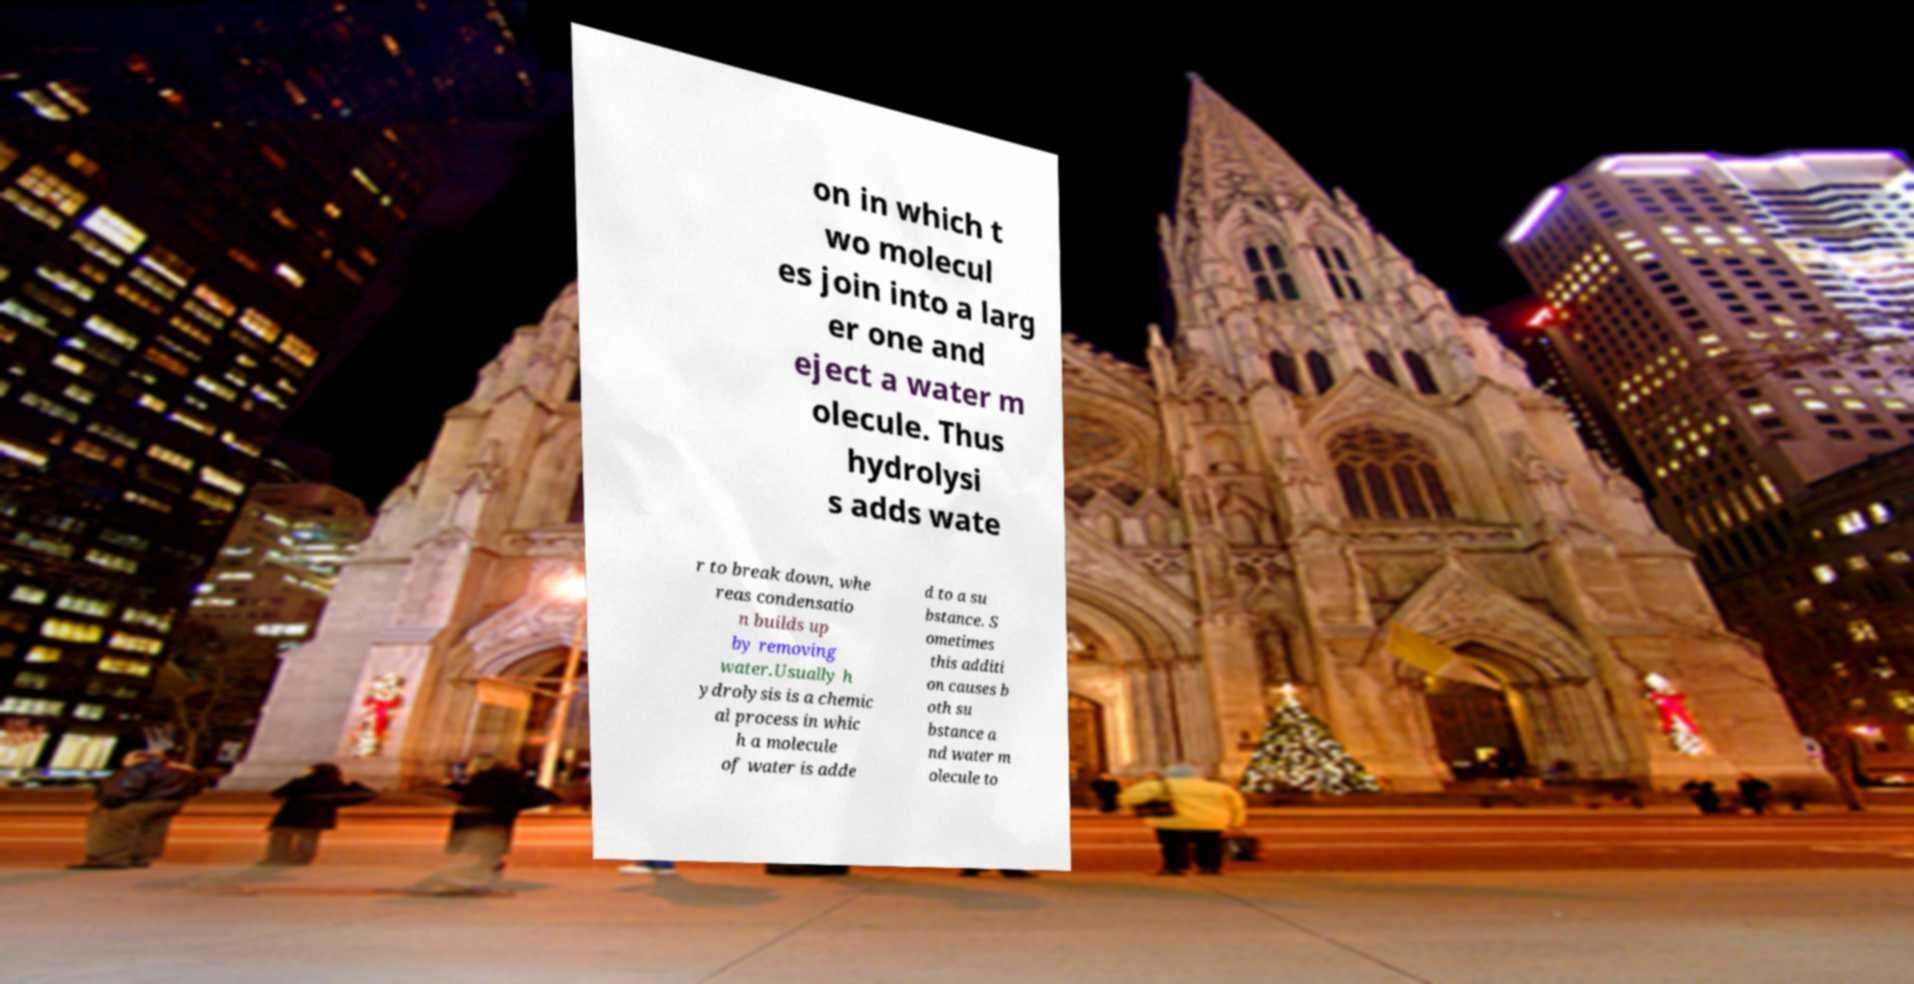For documentation purposes, I need the text within this image transcribed. Could you provide that? on in which t wo molecul es join into a larg er one and eject a water m olecule. Thus hydrolysi s adds wate r to break down, whe reas condensatio n builds up by removing water.Usually h ydrolysis is a chemic al process in whic h a molecule of water is adde d to a su bstance. S ometimes this additi on causes b oth su bstance a nd water m olecule to 